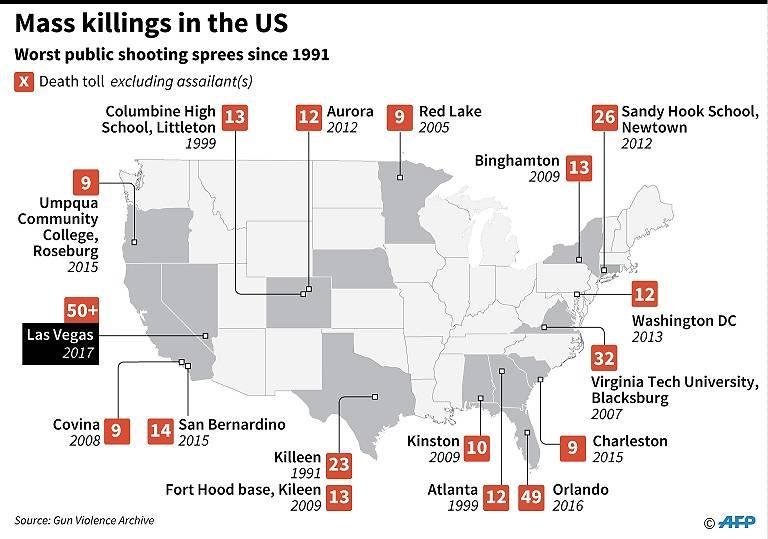Indicate a few pertinent items in this graphic. In the image, there are 17 listed public shooting incidents. The second incident with the highest death toll occurred in the city of Orlando. The shooting incident in Atlanta took place in the year 1999. The earliest shooting spree depicted in this image resulted in a death toll of 23. The most recent shooting spree depicted in this image resulted in a death toll of 50 or more individuals. 